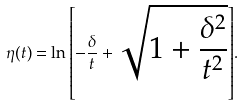Convert formula to latex. <formula><loc_0><loc_0><loc_500><loc_500>\eta ( t ) = \ln { \left [ - \frac { \delta } { t } + \sqrt { 1 + \frac { \delta ^ { 2 } } { t ^ { 2 } } } \right ] } .</formula> 